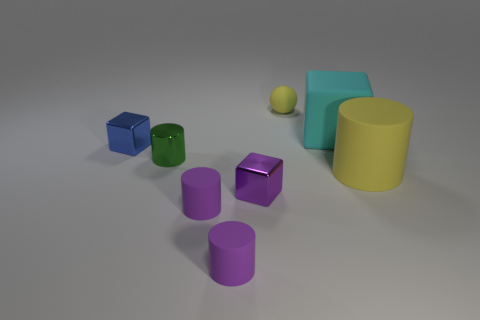Subtract all tiny purple blocks. How many blocks are left? 2 Subtract all yellow cylinders. How many cylinders are left? 3 Add 2 green shiny objects. How many objects exist? 10 Subtract 4 cylinders. How many cylinders are left? 0 Subtract 1 purple cubes. How many objects are left? 7 Subtract all balls. How many objects are left? 7 Subtract all green blocks. Subtract all cyan balls. How many blocks are left? 3 Subtract all cyan cylinders. How many blue cubes are left? 1 Subtract all rubber objects. Subtract all big things. How many objects are left? 1 Add 5 tiny purple shiny objects. How many tiny purple shiny objects are left? 6 